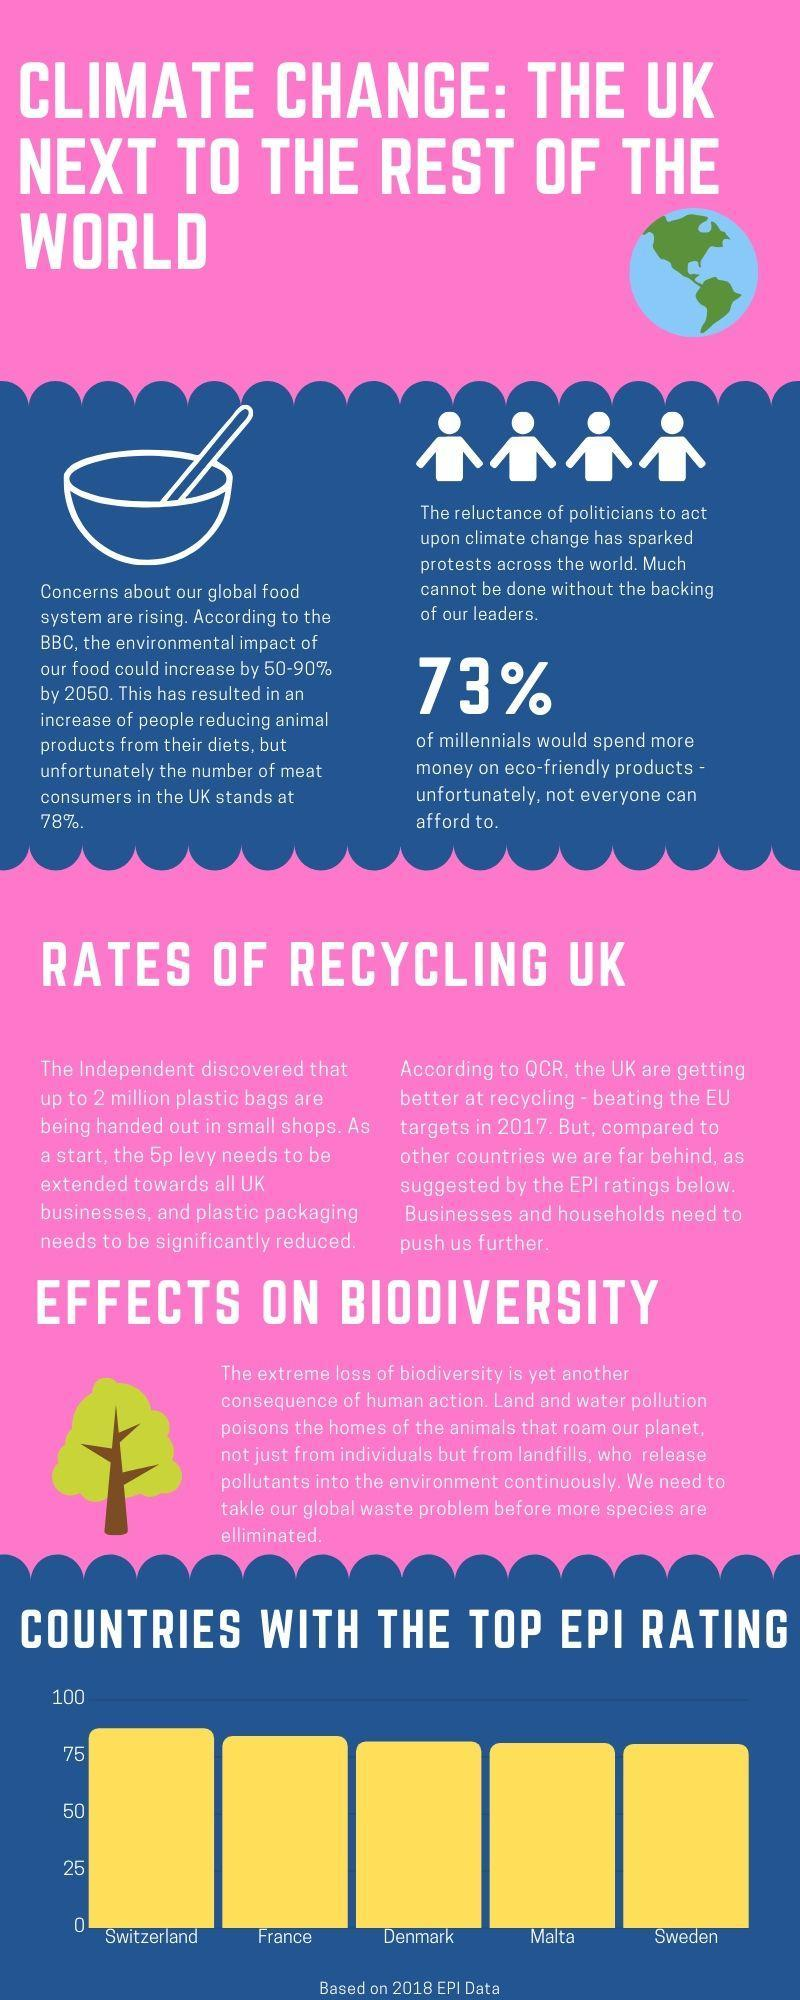What percent of millennials cannot afford eco-friendly products?
Answer the question with a short phrase. 27% What percent of people are not meat consumers in the UK? 22% Which country ranks fourth in top EPI rating based on 2018 data? MALTA 